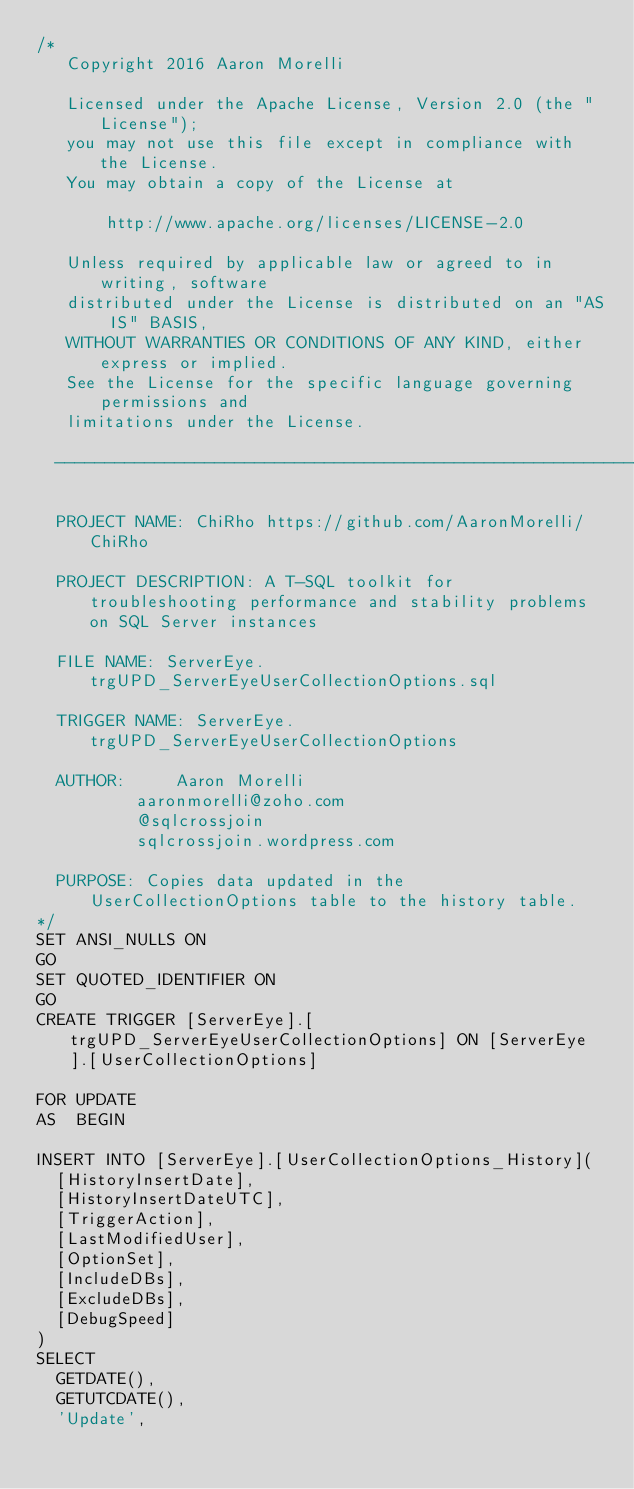Convert code to text. <code><loc_0><loc_0><loc_500><loc_500><_SQL_>/*
   Copyright 2016 Aaron Morelli

   Licensed under the Apache License, Version 2.0 (the "License");
   you may not use this file except in compliance with the License.
   You may obtain a copy of the License at

       http://www.apache.org/licenses/LICENSE-2.0

   Unless required by applicable law or agreed to in writing, software
   distributed under the License is distributed on an "AS IS" BASIS,
   WITHOUT WARRANTIES OR CONDITIONS OF ANY KIND, either express or implied.
   See the License for the specific language governing permissions and
   limitations under the License.

	------------------------------------------------------------------------

	PROJECT NAME: ChiRho https://github.com/AaronMorelli/ChiRho

	PROJECT DESCRIPTION: A T-SQL toolkit for troubleshooting performance and stability problems on SQL Server instances

	FILE NAME: ServerEye.trgUPD_ServerEyeUserCollectionOptions.sql

	TRIGGER NAME: ServerEye.trgUPD_ServerEyeUserCollectionOptions

	AUTHOR:			Aaron Morelli
					aaronmorelli@zoho.com
					@sqlcrossjoin
					sqlcrossjoin.wordpress.com

	PURPOSE: Copies data updated in the UserCollectionOptions table to the history table.
*/
SET ANSI_NULLS ON
GO
SET QUOTED_IDENTIFIER ON
GO
CREATE TRIGGER [ServerEye].[trgUPD_ServerEyeUserCollectionOptions] ON [ServerEye].[UserCollectionOptions]

FOR UPDATE
AS 	BEGIN

INSERT INTO [ServerEye].[UserCollectionOptions_History](
	[HistoryInsertDate],
	[HistoryInsertDateUTC],
	[TriggerAction],
	[LastModifiedUser],
	[OptionSet],
	[IncludeDBs],
	[ExcludeDBs],
	[DebugSpeed]
)
SELECT 
	GETDATE(),
	GETUTCDATE(),
	'Update',</code> 